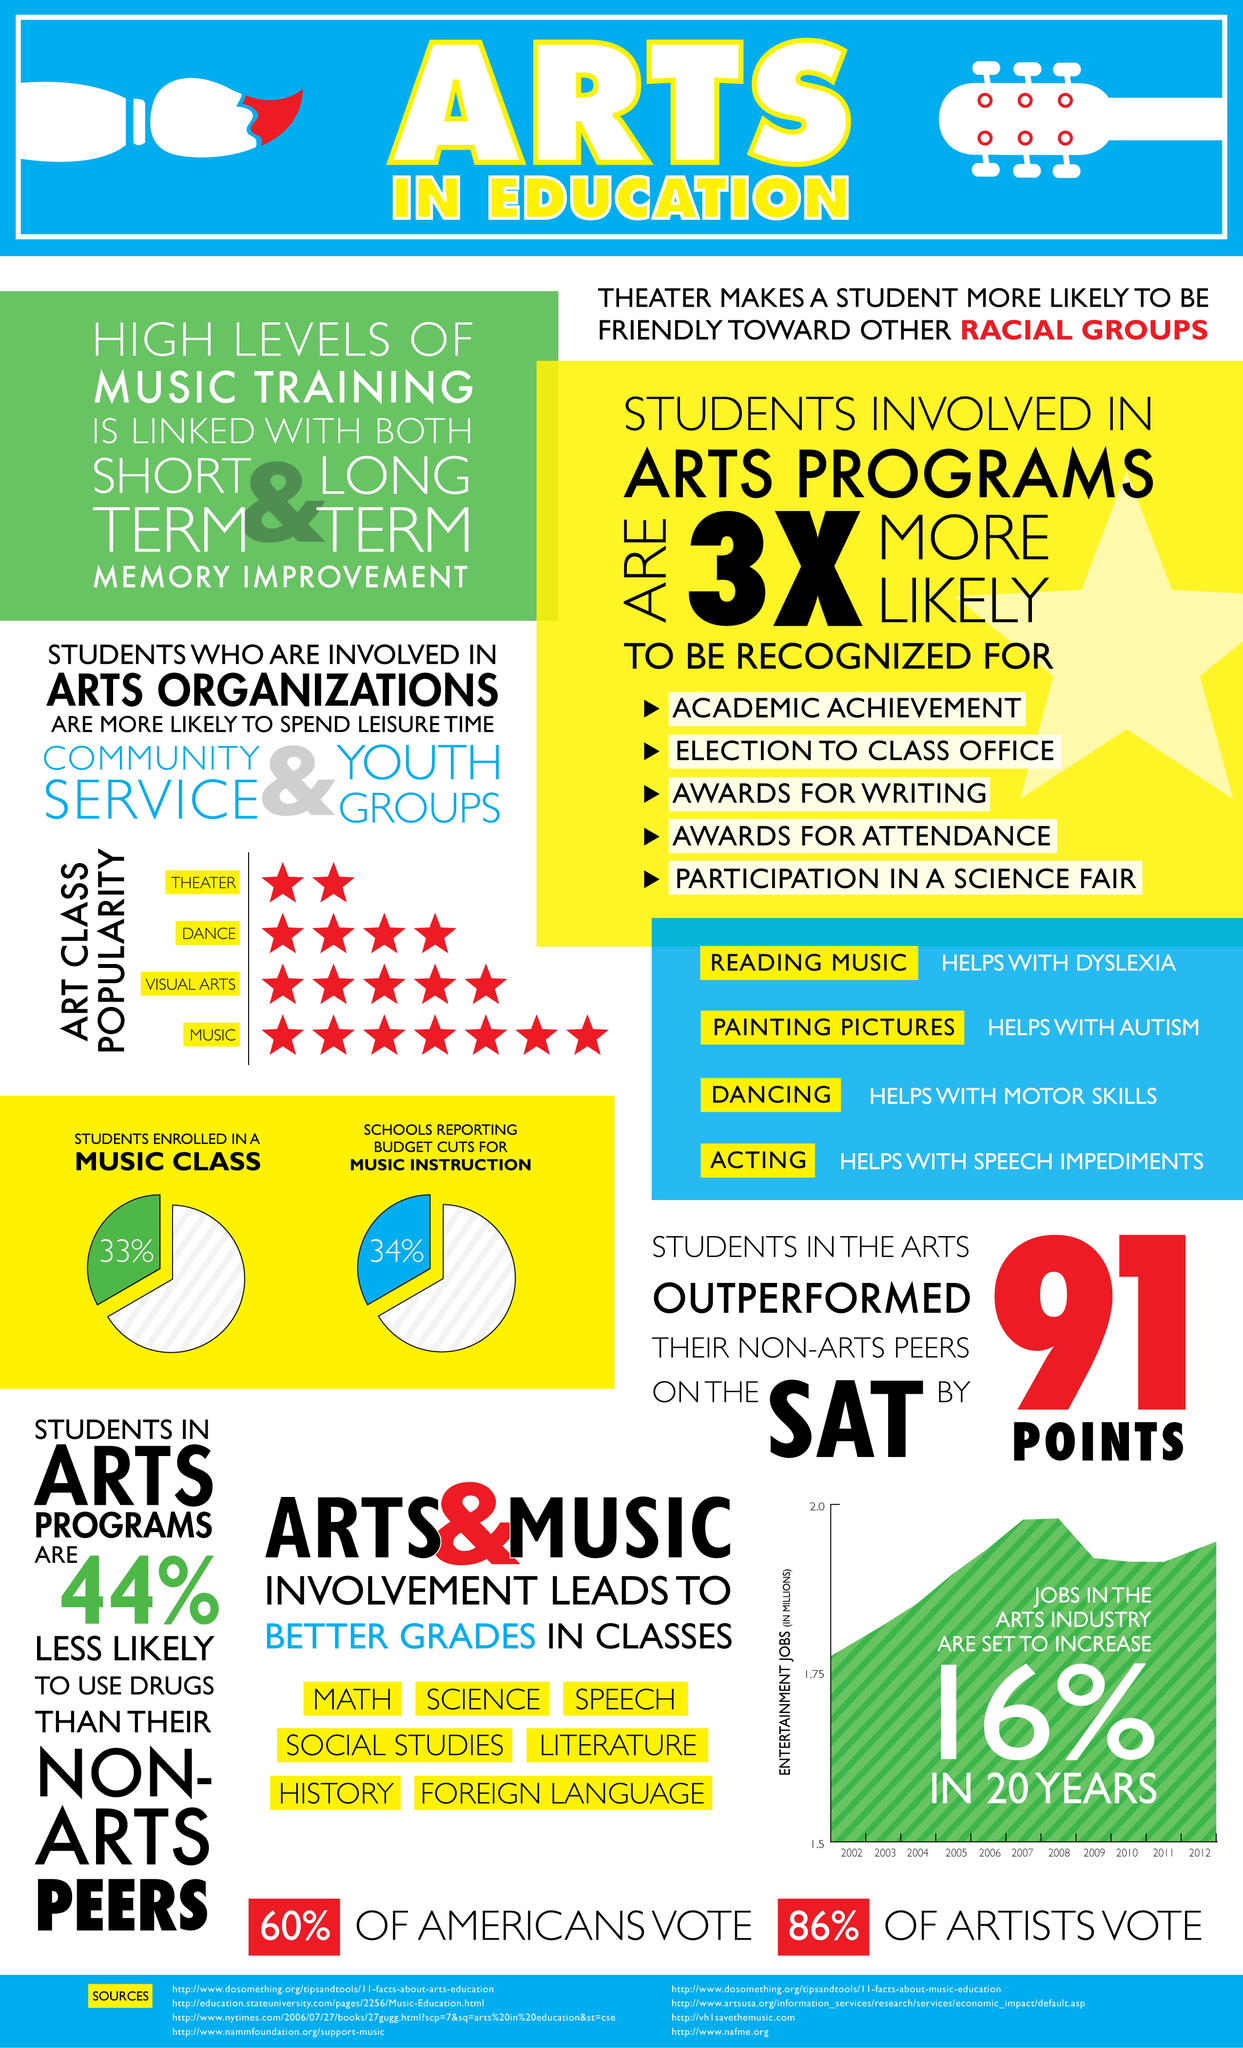Mention a couple of crucial points in this snapshot. According to the data, 67% of students are not enrolled in a music class. In the next 20 years, the arts industry is expected to experience a growth of 16% in job opportunities, indicating a promising future for individuals pursuing careers in the arts. 